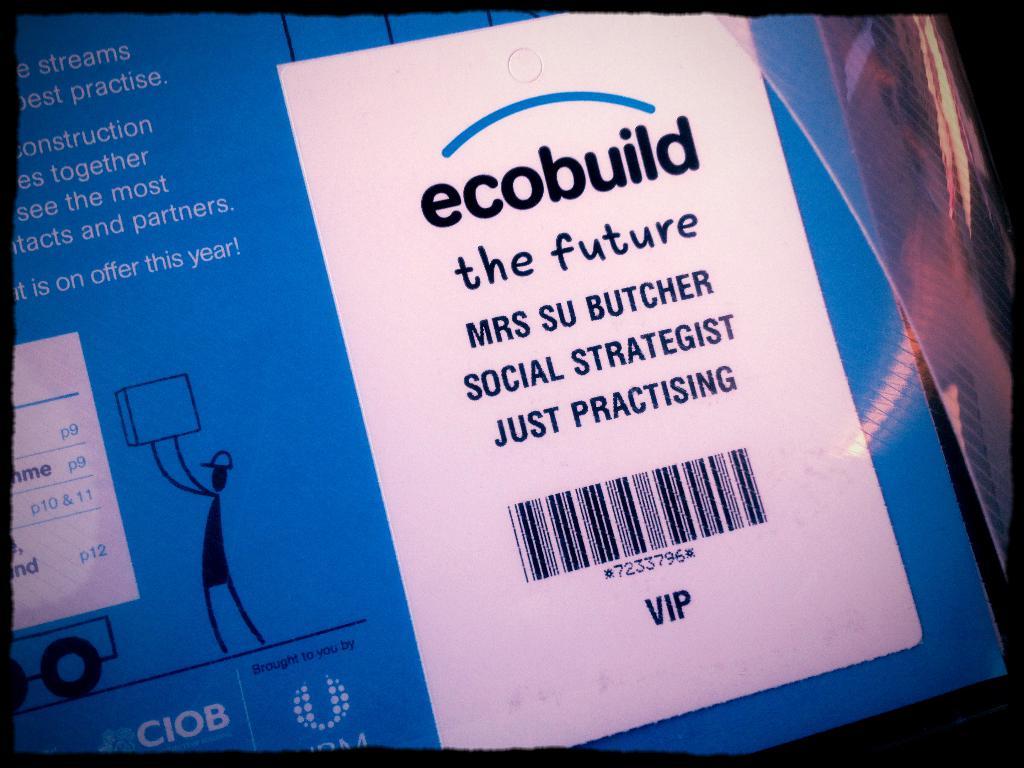What is the ecobuild anyways?
Keep it short and to the point. The future. Is this vip?
Keep it short and to the point. Yes. 